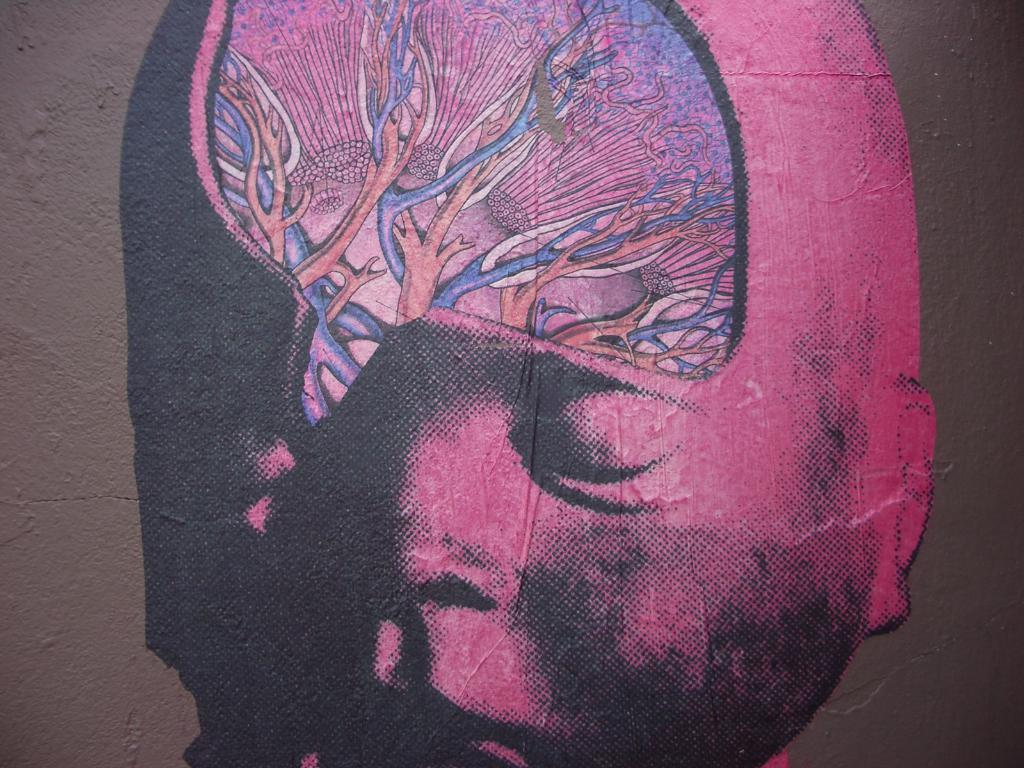What is hanging on the wall in the image? There is a painting on the wall in the image. What type of cup is being used to recite a verse in the image? There is no cup or verse present in the image; it only features a painting on the wall. 